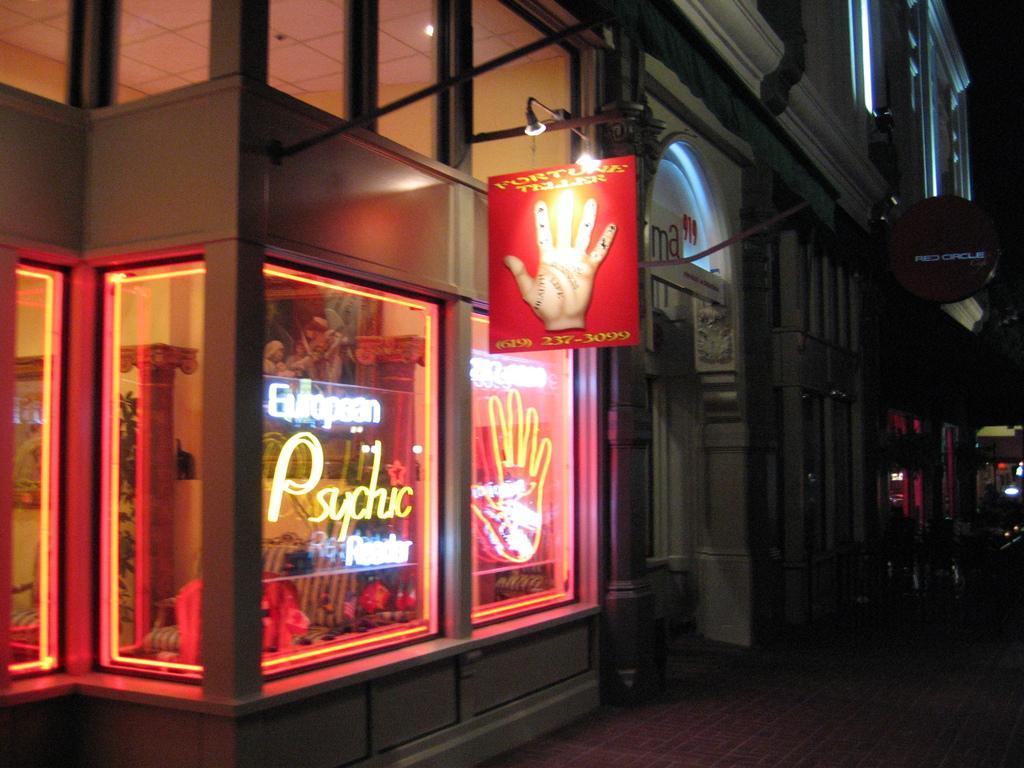In one or two sentences, can you explain what this image depicts? In this picture we can see store, boards, lights, wall, door, roof, glass are present. At the bottom of the image road is there. At the top right corner sky is there. 